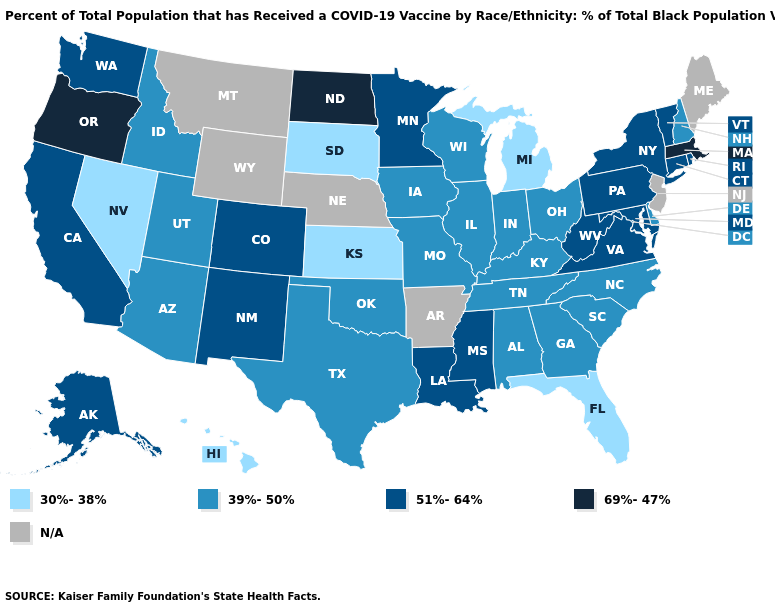What is the lowest value in the Northeast?
Write a very short answer. 39%-50%. How many symbols are there in the legend?
Concise answer only. 5. Does Oregon have the highest value in the USA?
Be succinct. Yes. What is the value of Delaware?
Quick response, please. 39%-50%. Which states have the lowest value in the USA?
Short answer required. Florida, Hawaii, Kansas, Michigan, Nevada, South Dakota. Does the first symbol in the legend represent the smallest category?
Be succinct. Yes. Does the map have missing data?
Be succinct. Yes. Does the map have missing data?
Write a very short answer. Yes. What is the value of Michigan?
Write a very short answer. 30%-38%. What is the highest value in states that border New Hampshire?
Be succinct. 69%-47%. What is the value of Missouri?
Be succinct. 39%-50%. Which states have the lowest value in the Northeast?
Quick response, please. New Hampshire. Name the states that have a value in the range 51%-64%?
Concise answer only. Alaska, California, Colorado, Connecticut, Louisiana, Maryland, Minnesota, Mississippi, New Mexico, New York, Pennsylvania, Rhode Island, Vermont, Virginia, Washington, West Virginia. Name the states that have a value in the range 30%-38%?
Quick response, please. Florida, Hawaii, Kansas, Michigan, Nevada, South Dakota. What is the value of Kansas?
Keep it brief. 30%-38%. 